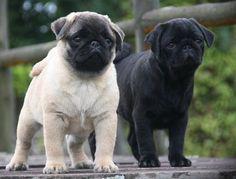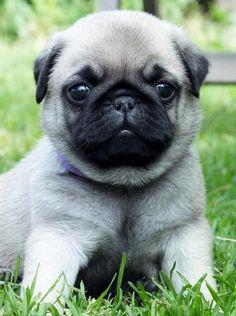The first image is the image on the left, the second image is the image on the right. For the images shown, is this caption "There is a single black dog looking at the camera." true? Answer yes or no. No. The first image is the image on the left, the second image is the image on the right. Assess this claim about the two images: "We've got three pups here.". Correct or not? Answer yes or no. Yes. 